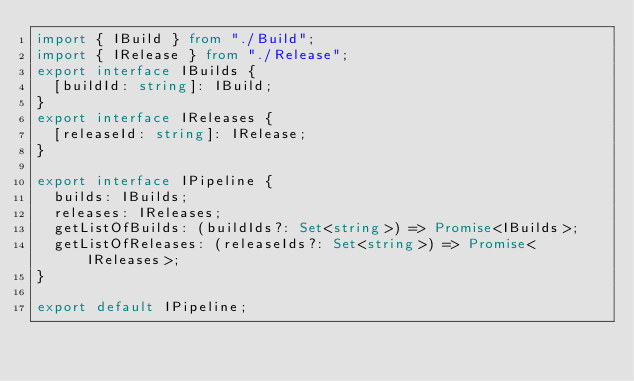<code> <loc_0><loc_0><loc_500><loc_500><_TypeScript_>import { IBuild } from "./Build";
import { IRelease } from "./Release";
export interface IBuilds {
  [buildId: string]: IBuild;
}
export interface IReleases {
  [releaseId: string]: IRelease;
}

export interface IPipeline {
  builds: IBuilds;
  releases: IReleases;
  getListOfBuilds: (buildIds?: Set<string>) => Promise<IBuilds>;
  getListOfReleases: (releaseIds?: Set<string>) => Promise<IReleases>;
}

export default IPipeline;
</code> 